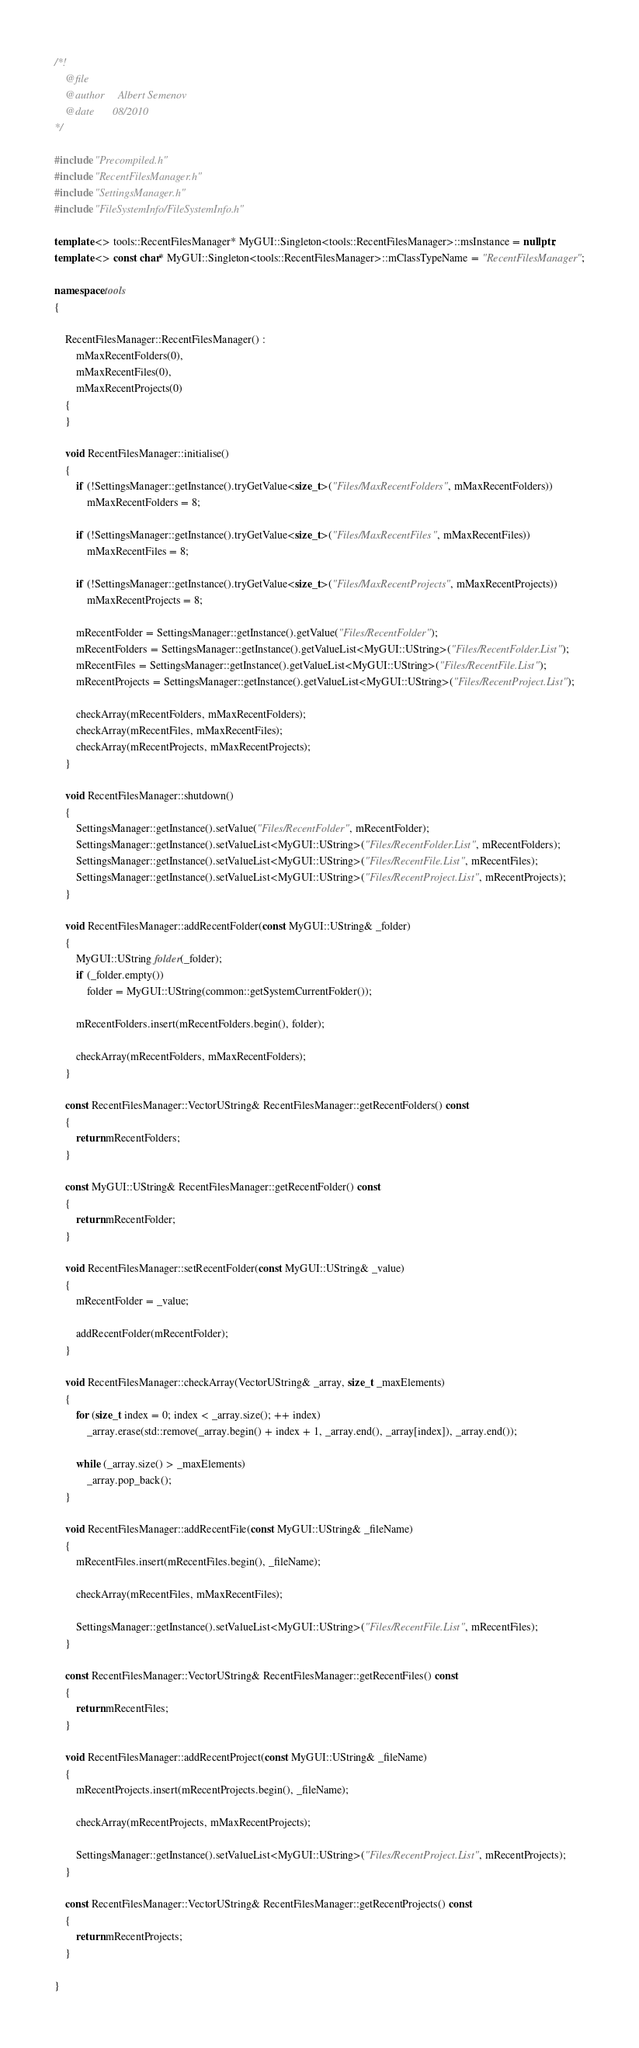Convert code to text. <code><loc_0><loc_0><loc_500><loc_500><_C++_>/*!
	@file
	@author		Albert Semenov
	@date		08/2010
*/

#include "Precompiled.h"
#include "RecentFilesManager.h"
#include "SettingsManager.h"
#include "FileSystemInfo/FileSystemInfo.h"

template <> tools::RecentFilesManager* MyGUI::Singleton<tools::RecentFilesManager>::msInstance = nullptr;
template <> const char* MyGUI::Singleton<tools::RecentFilesManager>::mClassTypeName = "RecentFilesManager";

namespace tools
{

	RecentFilesManager::RecentFilesManager() :
		mMaxRecentFolders(0),
		mMaxRecentFiles(0),
		mMaxRecentProjects(0)
	{
	}

	void RecentFilesManager::initialise()
	{
		if (!SettingsManager::getInstance().tryGetValue<size_t>("Files/MaxRecentFolders", mMaxRecentFolders))
			mMaxRecentFolders = 8;

		if (!SettingsManager::getInstance().tryGetValue<size_t>("Files/MaxRecentFiles", mMaxRecentFiles))
			mMaxRecentFiles = 8;

		if (!SettingsManager::getInstance().tryGetValue<size_t>("Files/MaxRecentProjects", mMaxRecentProjects))
			mMaxRecentProjects = 8;

		mRecentFolder = SettingsManager::getInstance().getValue("Files/RecentFolder");
		mRecentFolders = SettingsManager::getInstance().getValueList<MyGUI::UString>("Files/RecentFolder.List");
		mRecentFiles = SettingsManager::getInstance().getValueList<MyGUI::UString>("Files/RecentFile.List");
		mRecentProjects = SettingsManager::getInstance().getValueList<MyGUI::UString>("Files/RecentProject.List");

		checkArray(mRecentFolders, mMaxRecentFolders);
		checkArray(mRecentFiles, mMaxRecentFiles);
		checkArray(mRecentProjects, mMaxRecentProjects);
	}

	void RecentFilesManager::shutdown()
	{
		SettingsManager::getInstance().setValue("Files/RecentFolder", mRecentFolder);
		SettingsManager::getInstance().setValueList<MyGUI::UString>("Files/RecentFolder.List", mRecentFolders);
		SettingsManager::getInstance().setValueList<MyGUI::UString>("Files/RecentFile.List", mRecentFiles);
		SettingsManager::getInstance().setValueList<MyGUI::UString>("Files/RecentProject.List", mRecentProjects);
	}

	void RecentFilesManager::addRecentFolder(const MyGUI::UString& _folder)
	{
		MyGUI::UString folder(_folder);
		if (_folder.empty())
			folder = MyGUI::UString(common::getSystemCurrentFolder());

		mRecentFolders.insert(mRecentFolders.begin(), folder);

		checkArray(mRecentFolders, mMaxRecentFolders);
	}

	const RecentFilesManager::VectorUString& RecentFilesManager::getRecentFolders() const
	{
		return mRecentFolders;
	}

	const MyGUI::UString& RecentFilesManager::getRecentFolder() const
	{
		return mRecentFolder;
	}

	void RecentFilesManager::setRecentFolder(const MyGUI::UString& _value)
	{
		mRecentFolder = _value;

		addRecentFolder(mRecentFolder);
	}

	void RecentFilesManager::checkArray(VectorUString& _array, size_t _maxElements)
	{
		for (size_t index = 0; index < _array.size(); ++ index)
			_array.erase(std::remove(_array.begin() + index + 1, _array.end(), _array[index]), _array.end());

		while (_array.size() > _maxElements)
			_array.pop_back();
	}

	void RecentFilesManager::addRecentFile(const MyGUI::UString& _fileName)
	{
		mRecentFiles.insert(mRecentFiles.begin(), _fileName);

		checkArray(mRecentFiles, mMaxRecentFiles);

		SettingsManager::getInstance().setValueList<MyGUI::UString>("Files/RecentFile.List", mRecentFiles);
	}

	const RecentFilesManager::VectorUString& RecentFilesManager::getRecentFiles() const
	{
		return mRecentFiles;
	}

	void RecentFilesManager::addRecentProject(const MyGUI::UString& _fileName)
	{
		mRecentProjects.insert(mRecentProjects.begin(), _fileName);

		checkArray(mRecentProjects, mMaxRecentProjects);

		SettingsManager::getInstance().setValueList<MyGUI::UString>("Files/RecentProject.List", mRecentProjects);
	}

	const RecentFilesManager::VectorUString& RecentFilesManager::getRecentProjects() const
	{
		return mRecentProjects;
	}

}
</code> 